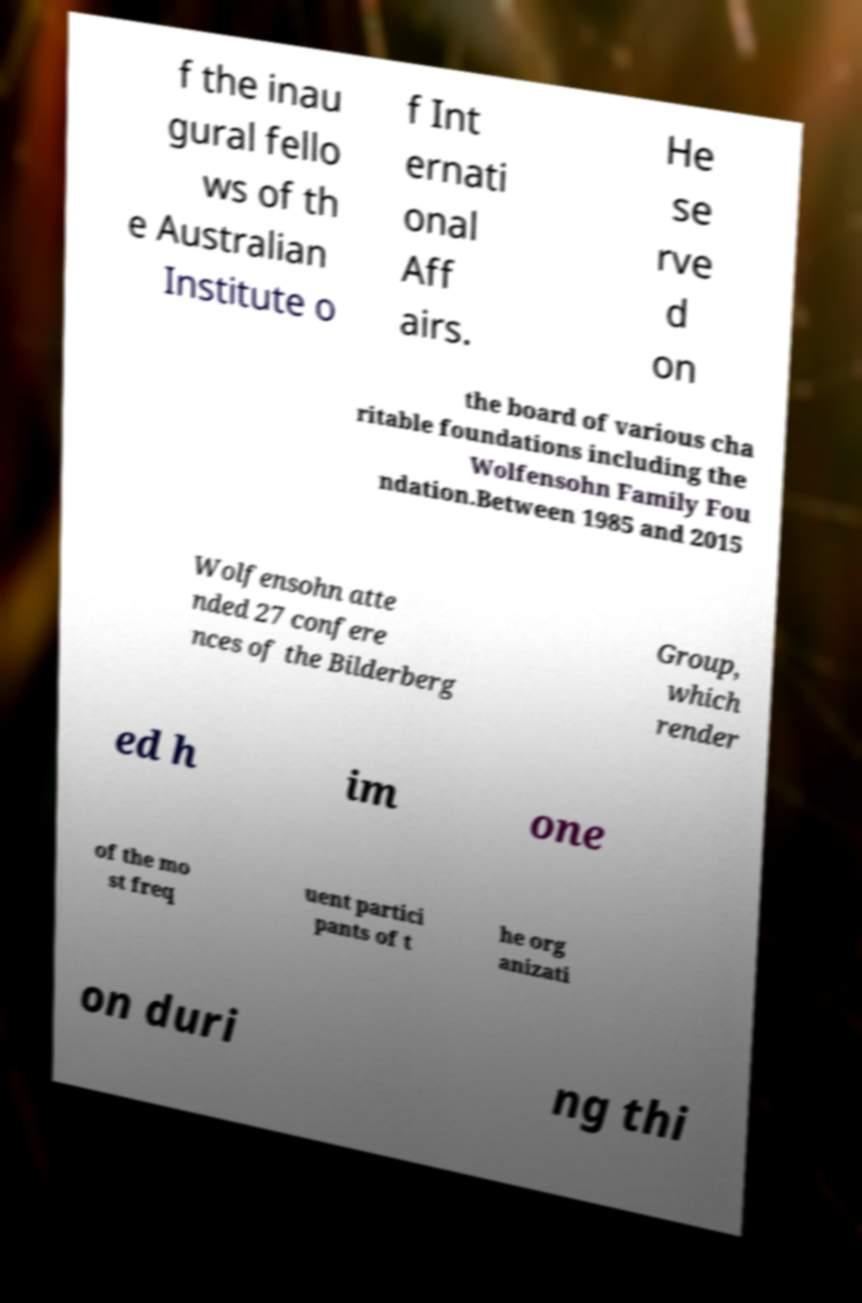Please identify and transcribe the text found in this image. f the inau gural fello ws of th e Australian Institute o f Int ernati onal Aff airs. He se rve d on the board of various cha ritable foundations including the Wolfensohn Family Fou ndation.Between 1985 and 2015 Wolfensohn atte nded 27 confere nces of the Bilderberg Group, which render ed h im one of the mo st freq uent partici pants of t he org anizati on duri ng thi 